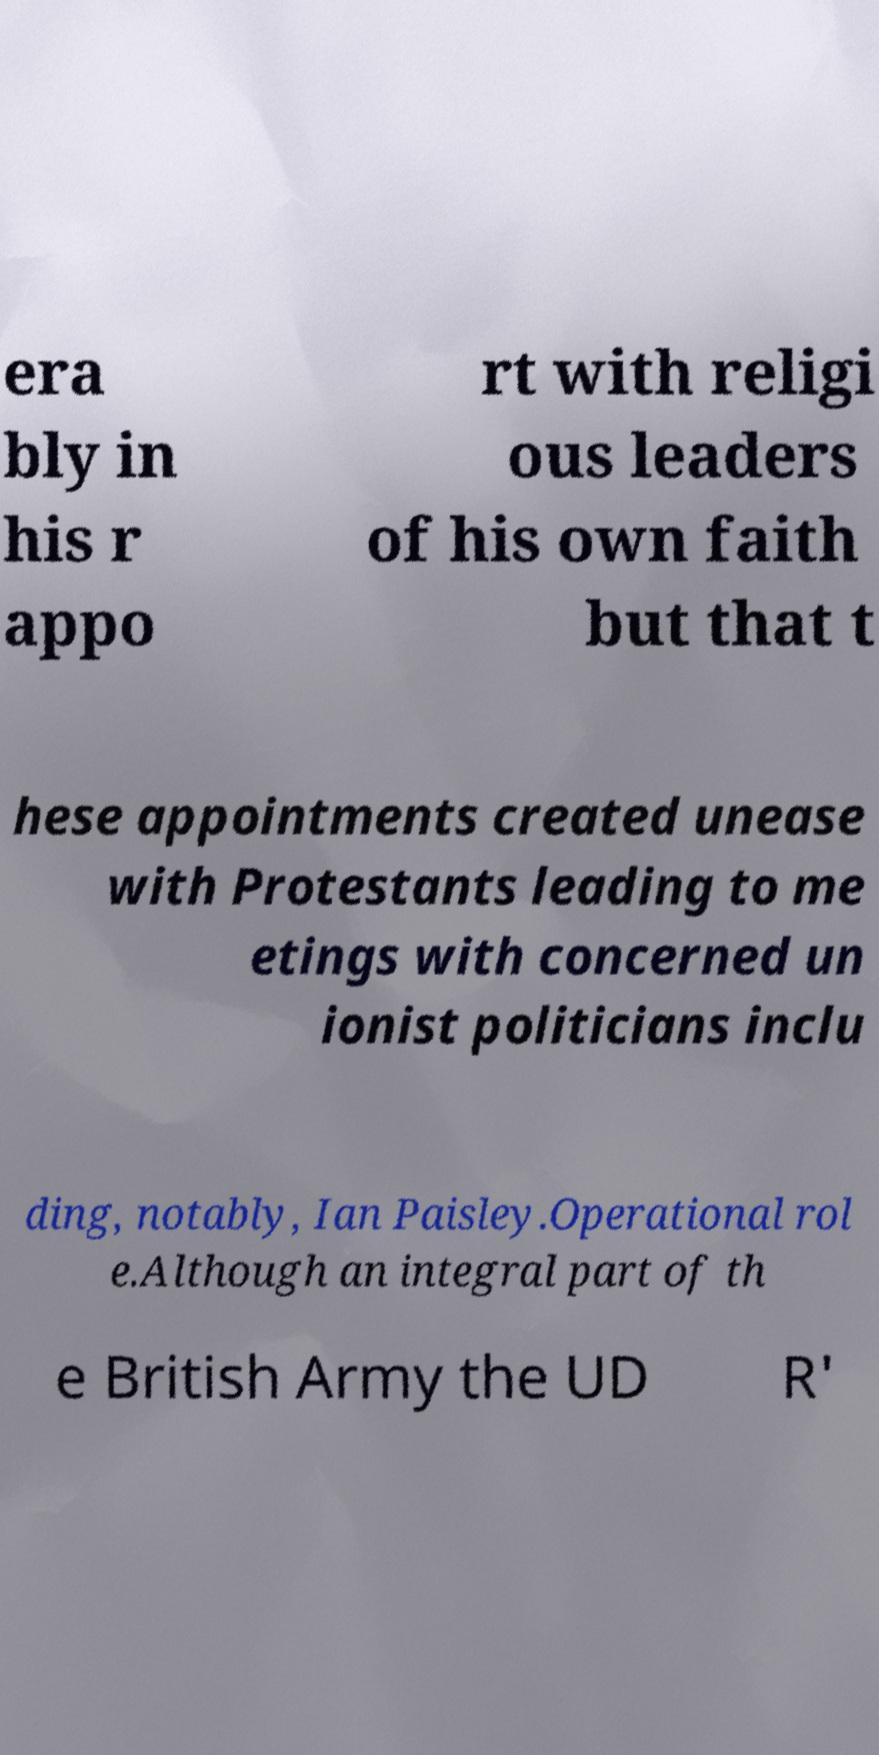Can you read and provide the text displayed in the image?This photo seems to have some interesting text. Can you extract and type it out for me? era bly in his r appo rt with religi ous leaders of his own faith but that t hese appointments created unease with Protestants leading to me etings with concerned un ionist politicians inclu ding, notably, Ian Paisley.Operational rol e.Although an integral part of th e British Army the UD R' 